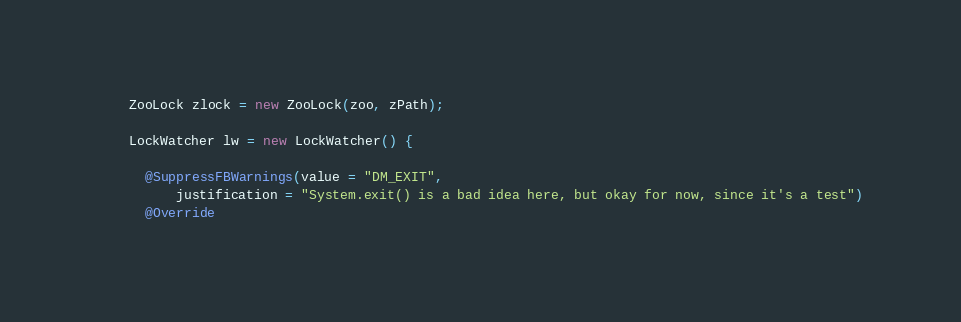Convert code to text. <code><loc_0><loc_0><loc_500><loc_500><_Java_>
    ZooLock zlock = new ZooLock(zoo, zPath);

    LockWatcher lw = new LockWatcher() {

      @SuppressFBWarnings(value = "DM_EXIT",
          justification = "System.exit() is a bad idea here, but okay for now, since it's a test")
      @Override</code> 